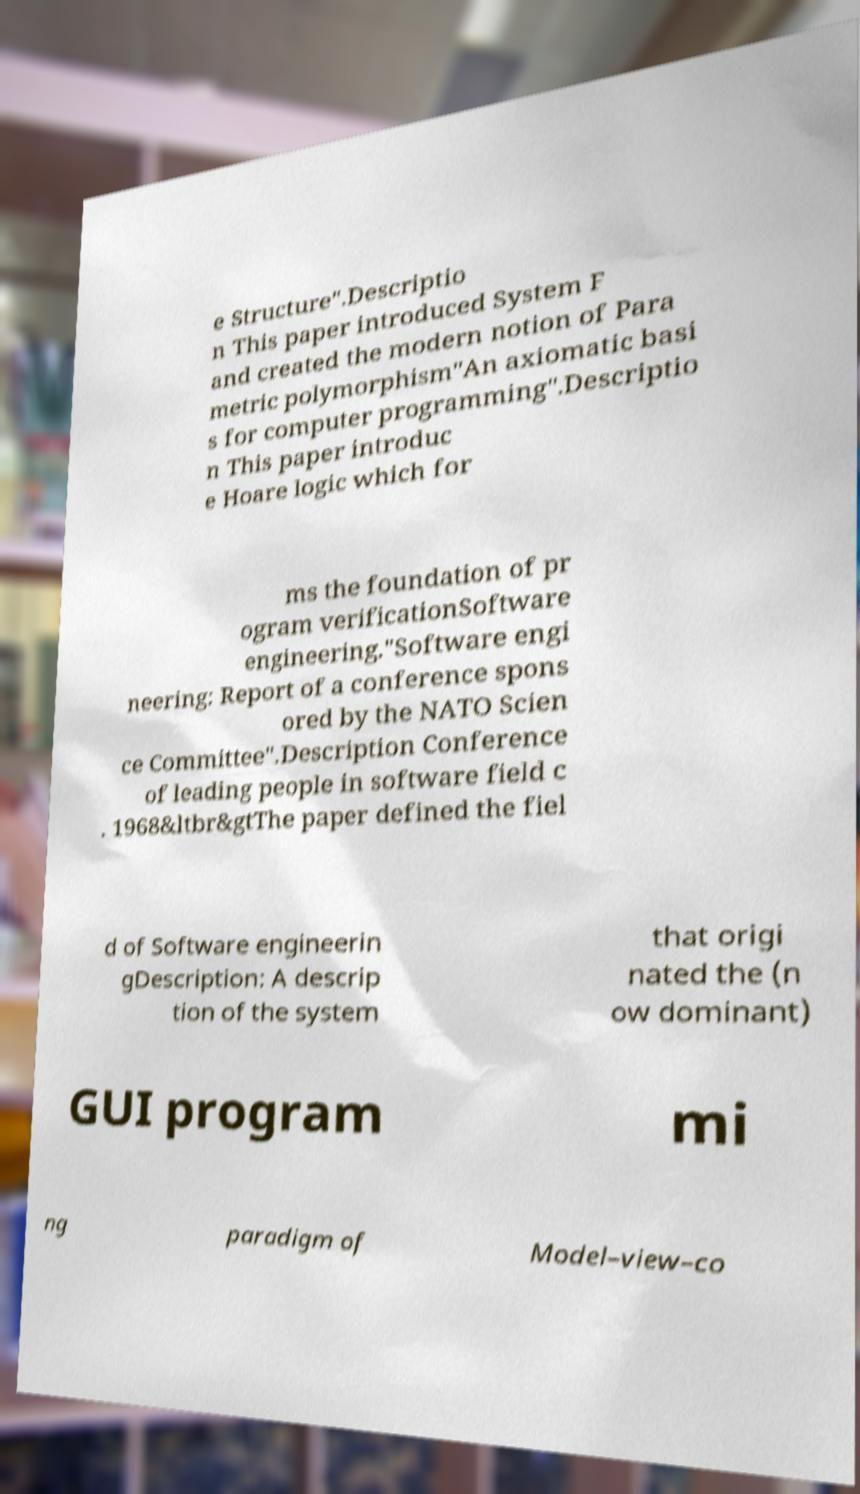I need the written content from this picture converted into text. Can you do that? e Structure".Descriptio n This paper introduced System F and created the modern notion of Para metric polymorphism"An axiomatic basi s for computer programming".Descriptio n This paper introduc e Hoare logic which for ms the foundation of pr ogram verificationSoftware engineering."Software engi neering: Report of a conference spons ored by the NATO Scien ce Committee".Description Conference of leading people in software field c . 1968&ltbr&gtThe paper defined the fiel d of Software engineerin gDescription: A descrip tion of the system that origi nated the (n ow dominant) GUI program mi ng paradigm of Model–view–co 